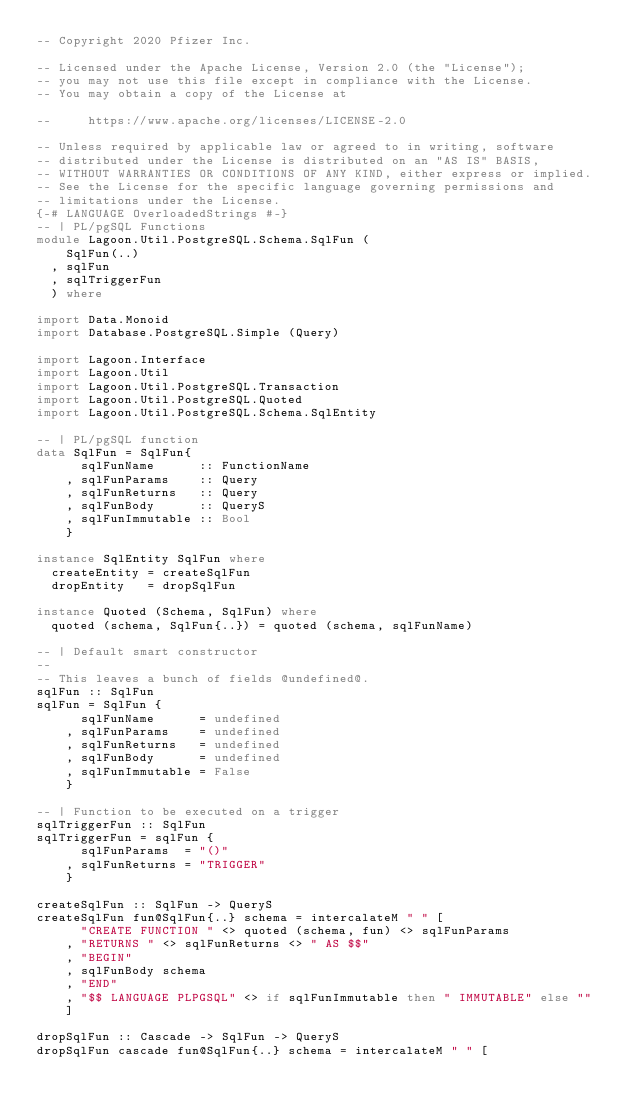<code> <loc_0><loc_0><loc_500><loc_500><_Haskell_>-- Copyright 2020 Pfizer Inc.

-- Licensed under the Apache License, Version 2.0 (the "License");
-- you may not use this file except in compliance with the License.
-- You may obtain a copy of the License at

--     https://www.apache.org/licenses/LICENSE-2.0

-- Unless required by applicable law or agreed to in writing, software
-- distributed under the License is distributed on an "AS IS" BASIS,
-- WITHOUT WARRANTIES OR CONDITIONS OF ANY KIND, either express or implied.
-- See the License for the specific language governing permissions and
-- limitations under the License.
{-# LANGUAGE OverloadedStrings #-}
-- | PL/pgSQL Functions
module Lagoon.Util.PostgreSQL.Schema.SqlFun (
    SqlFun(..)
  , sqlFun
  , sqlTriggerFun
  ) where

import Data.Monoid
import Database.PostgreSQL.Simple (Query)

import Lagoon.Interface
import Lagoon.Util
import Lagoon.Util.PostgreSQL.Transaction
import Lagoon.Util.PostgreSQL.Quoted
import Lagoon.Util.PostgreSQL.Schema.SqlEntity

-- | PL/pgSQL function
data SqlFun = SqlFun{
      sqlFunName      :: FunctionName
    , sqlFunParams    :: Query
    , sqlFunReturns   :: Query
    , sqlFunBody      :: QueryS
    , sqlFunImmutable :: Bool
    }

instance SqlEntity SqlFun where
  createEntity = createSqlFun
  dropEntity   = dropSqlFun

instance Quoted (Schema, SqlFun) where
  quoted (schema, SqlFun{..}) = quoted (schema, sqlFunName)

-- | Default smart constructor
--
-- This leaves a bunch of fields @undefined@.
sqlFun :: SqlFun
sqlFun = SqlFun {
      sqlFunName      = undefined
    , sqlFunParams    = undefined
    , sqlFunReturns   = undefined
    , sqlFunBody      = undefined
    , sqlFunImmutable = False
    }

-- | Function to be executed on a trigger
sqlTriggerFun :: SqlFun
sqlTriggerFun = sqlFun {
      sqlFunParams  = "()"
    , sqlFunReturns = "TRIGGER"
    }

createSqlFun :: SqlFun -> QueryS
createSqlFun fun@SqlFun{..} schema = intercalateM " " [
      "CREATE FUNCTION " <> quoted (schema, fun) <> sqlFunParams
    , "RETURNS " <> sqlFunReturns <> " AS $$"
    , "BEGIN"
    , sqlFunBody schema
    , "END"
    , "$$ LANGUAGE PLPGSQL" <> if sqlFunImmutable then " IMMUTABLE" else ""
    ]

dropSqlFun :: Cascade -> SqlFun -> QueryS
dropSqlFun cascade fun@SqlFun{..} schema = intercalateM " " [</code> 